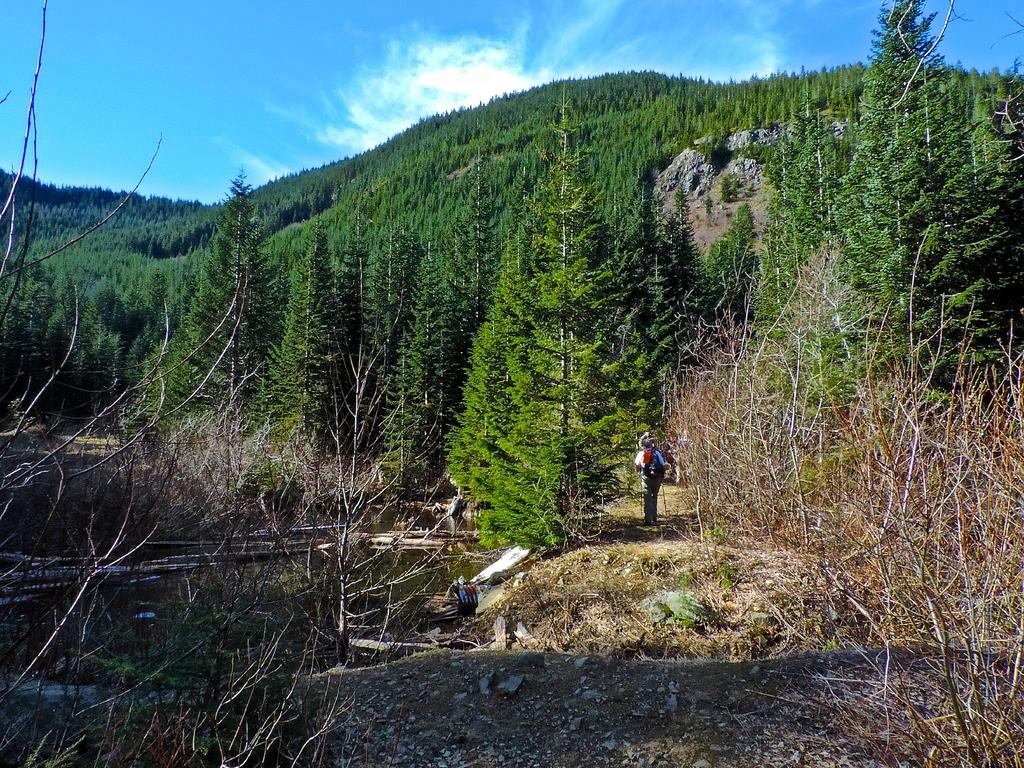What type of vegetation can be seen in the image? There are trees in the image. What else can be seen on the ground in the image? There is grass in the image. What is visible in the water in the image? The water is visible in the image, but it is not clear what is in it. What is visible in the background of the image? The sky is visible in the background of the image. What can be seen in the sky? Clouds are present in the sky. What type of light is shining on the trees in the image? There is no specific light source mentioned in the image, so it is not possible to determine the type of light shining on the trees. Can you see a body of water in the image? The image only mentions water being visible, but it does not specify whether it is a body of water or not. 